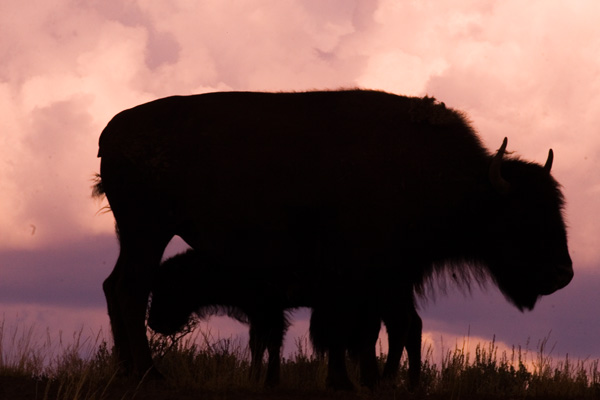What might be the significance of depicting the animal this way? Depicting the animal as a silhouette creates a dramatic and powerful image. It emphasizes the animal's shape and form, making it an iconic representation of the species and possibly invoking a sense of the animal's presence in its natural habitat. Is there a deeper meaning to this kind of portrayal? Such images can evoke themes of nature's majesty, solitude, or the wild, untouched landscapes. It may also reflect on the plight of the species, hinting at themes of conservation and the importance of preserving natural environments. 